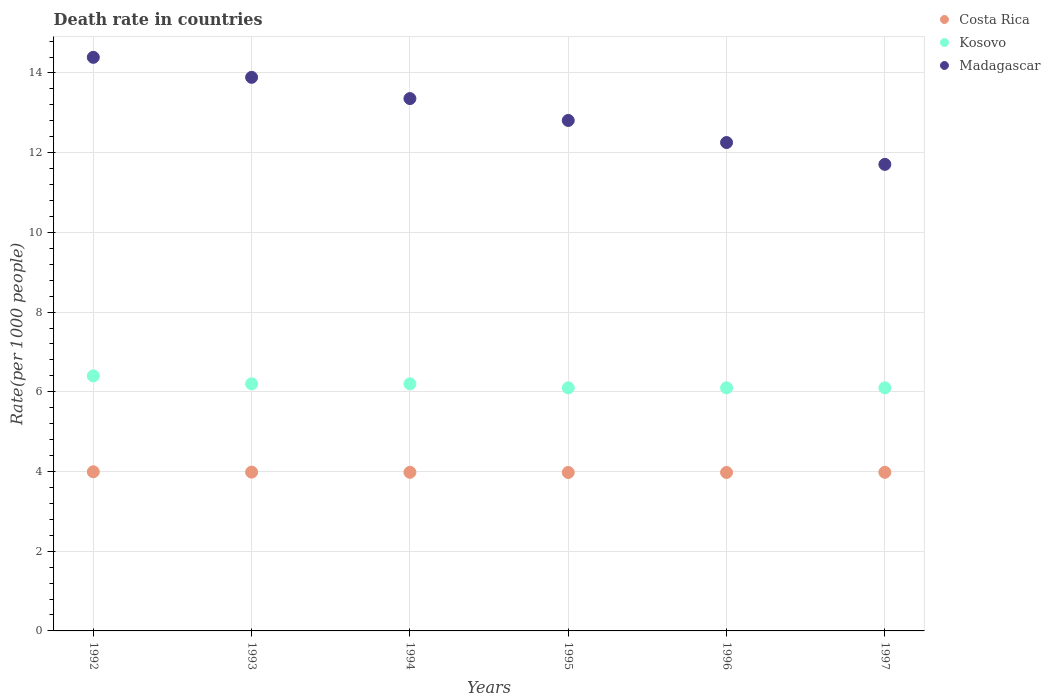How many different coloured dotlines are there?
Offer a terse response. 3. What is the death rate in Madagascar in 1996?
Provide a short and direct response. 12.26. Across all years, what is the maximum death rate in Costa Rica?
Offer a very short reply. 3.99. Across all years, what is the minimum death rate in Costa Rica?
Give a very brief answer. 3.98. In which year was the death rate in Madagascar minimum?
Provide a succinct answer. 1997. What is the total death rate in Costa Rica in the graph?
Keep it short and to the point. 23.89. What is the difference between the death rate in Kosovo in 1996 and that in 1997?
Offer a terse response. 0. What is the difference between the death rate in Costa Rica in 1994 and the death rate in Madagascar in 1996?
Your response must be concise. -8.28. What is the average death rate in Kosovo per year?
Your answer should be very brief. 6.18. In the year 1995, what is the difference between the death rate in Kosovo and death rate in Costa Rica?
Ensure brevity in your answer.  2.12. In how many years, is the death rate in Kosovo greater than 1.2000000000000002?
Offer a very short reply. 6. What is the ratio of the death rate in Madagascar in 1993 to that in 1997?
Your answer should be compact. 1.19. Is the difference between the death rate in Kosovo in 1992 and 1996 greater than the difference between the death rate in Costa Rica in 1992 and 1996?
Offer a terse response. Yes. What is the difference between the highest and the second highest death rate in Kosovo?
Offer a terse response. 0.2. What is the difference between the highest and the lowest death rate in Kosovo?
Provide a short and direct response. 0.3. Is the sum of the death rate in Madagascar in 1994 and 1997 greater than the maximum death rate in Costa Rica across all years?
Keep it short and to the point. Yes. Is it the case that in every year, the sum of the death rate in Costa Rica and death rate in Kosovo  is greater than the death rate in Madagascar?
Offer a very short reply. No. How many dotlines are there?
Your response must be concise. 3. How many years are there in the graph?
Make the answer very short. 6. What is the difference between two consecutive major ticks on the Y-axis?
Provide a short and direct response. 2. Does the graph contain any zero values?
Your answer should be compact. No. Where does the legend appear in the graph?
Ensure brevity in your answer.  Top right. How are the legend labels stacked?
Provide a succinct answer. Vertical. What is the title of the graph?
Offer a terse response. Death rate in countries. Does "Latin America(all income levels)" appear as one of the legend labels in the graph?
Your answer should be compact. No. What is the label or title of the X-axis?
Provide a succinct answer. Years. What is the label or title of the Y-axis?
Ensure brevity in your answer.  Rate(per 1000 people). What is the Rate(per 1000 people) in Costa Rica in 1992?
Keep it short and to the point. 3.99. What is the Rate(per 1000 people) in Madagascar in 1992?
Offer a terse response. 14.39. What is the Rate(per 1000 people) of Costa Rica in 1993?
Your response must be concise. 3.98. What is the Rate(per 1000 people) of Madagascar in 1993?
Make the answer very short. 13.89. What is the Rate(per 1000 people) in Costa Rica in 1994?
Provide a short and direct response. 3.98. What is the Rate(per 1000 people) in Madagascar in 1994?
Ensure brevity in your answer.  13.36. What is the Rate(per 1000 people) in Costa Rica in 1995?
Give a very brief answer. 3.98. What is the Rate(per 1000 people) in Kosovo in 1995?
Your response must be concise. 6.1. What is the Rate(per 1000 people) of Madagascar in 1995?
Your response must be concise. 12.81. What is the Rate(per 1000 people) in Costa Rica in 1996?
Keep it short and to the point. 3.98. What is the Rate(per 1000 people) in Madagascar in 1996?
Offer a terse response. 12.26. What is the Rate(per 1000 people) in Costa Rica in 1997?
Your answer should be compact. 3.98. What is the Rate(per 1000 people) in Kosovo in 1997?
Make the answer very short. 6.1. What is the Rate(per 1000 people) of Madagascar in 1997?
Offer a very short reply. 11.71. Across all years, what is the maximum Rate(per 1000 people) in Costa Rica?
Your answer should be very brief. 3.99. Across all years, what is the maximum Rate(per 1000 people) in Kosovo?
Offer a very short reply. 6.4. Across all years, what is the maximum Rate(per 1000 people) of Madagascar?
Keep it short and to the point. 14.39. Across all years, what is the minimum Rate(per 1000 people) in Costa Rica?
Your response must be concise. 3.98. Across all years, what is the minimum Rate(per 1000 people) in Kosovo?
Offer a very short reply. 6.1. Across all years, what is the minimum Rate(per 1000 people) of Madagascar?
Give a very brief answer. 11.71. What is the total Rate(per 1000 people) in Costa Rica in the graph?
Provide a succinct answer. 23.89. What is the total Rate(per 1000 people) in Kosovo in the graph?
Make the answer very short. 37.1. What is the total Rate(per 1000 people) in Madagascar in the graph?
Provide a short and direct response. 78.41. What is the difference between the Rate(per 1000 people) of Costa Rica in 1992 and that in 1993?
Your answer should be compact. 0.01. What is the difference between the Rate(per 1000 people) in Madagascar in 1992 and that in 1993?
Ensure brevity in your answer.  0.5. What is the difference between the Rate(per 1000 people) of Costa Rica in 1992 and that in 1994?
Offer a terse response. 0.01. What is the difference between the Rate(per 1000 people) in Madagascar in 1992 and that in 1994?
Your response must be concise. 1.03. What is the difference between the Rate(per 1000 people) of Costa Rica in 1992 and that in 1995?
Ensure brevity in your answer.  0.02. What is the difference between the Rate(per 1000 people) of Kosovo in 1992 and that in 1995?
Offer a terse response. 0.3. What is the difference between the Rate(per 1000 people) of Madagascar in 1992 and that in 1995?
Provide a short and direct response. 1.58. What is the difference between the Rate(per 1000 people) of Costa Rica in 1992 and that in 1996?
Offer a terse response. 0.02. What is the difference between the Rate(per 1000 people) in Kosovo in 1992 and that in 1996?
Provide a short and direct response. 0.3. What is the difference between the Rate(per 1000 people) in Madagascar in 1992 and that in 1996?
Keep it short and to the point. 2.14. What is the difference between the Rate(per 1000 people) of Costa Rica in 1992 and that in 1997?
Your answer should be very brief. 0.01. What is the difference between the Rate(per 1000 people) in Kosovo in 1992 and that in 1997?
Your response must be concise. 0.3. What is the difference between the Rate(per 1000 people) of Madagascar in 1992 and that in 1997?
Make the answer very short. 2.69. What is the difference between the Rate(per 1000 people) in Costa Rica in 1993 and that in 1994?
Your answer should be compact. 0.01. What is the difference between the Rate(per 1000 people) of Madagascar in 1993 and that in 1994?
Your response must be concise. 0.53. What is the difference between the Rate(per 1000 people) of Costa Rica in 1993 and that in 1995?
Keep it short and to the point. 0.01. What is the difference between the Rate(per 1000 people) in Madagascar in 1993 and that in 1995?
Offer a terse response. 1.08. What is the difference between the Rate(per 1000 people) of Costa Rica in 1993 and that in 1996?
Keep it short and to the point. 0.01. What is the difference between the Rate(per 1000 people) in Madagascar in 1993 and that in 1996?
Keep it short and to the point. 1.64. What is the difference between the Rate(per 1000 people) of Costa Rica in 1993 and that in 1997?
Offer a terse response. 0.01. What is the difference between the Rate(per 1000 people) of Kosovo in 1993 and that in 1997?
Ensure brevity in your answer.  0.1. What is the difference between the Rate(per 1000 people) in Madagascar in 1993 and that in 1997?
Offer a very short reply. 2.18. What is the difference between the Rate(per 1000 people) in Costa Rica in 1994 and that in 1995?
Your answer should be very brief. 0. What is the difference between the Rate(per 1000 people) in Kosovo in 1994 and that in 1995?
Your answer should be very brief. 0.1. What is the difference between the Rate(per 1000 people) in Madagascar in 1994 and that in 1995?
Ensure brevity in your answer.  0.55. What is the difference between the Rate(per 1000 people) of Costa Rica in 1994 and that in 1996?
Provide a succinct answer. 0. What is the difference between the Rate(per 1000 people) in Madagascar in 1994 and that in 1996?
Give a very brief answer. 1.1. What is the difference between the Rate(per 1000 people) of Costa Rica in 1994 and that in 1997?
Provide a short and direct response. 0. What is the difference between the Rate(per 1000 people) of Madagascar in 1994 and that in 1997?
Your response must be concise. 1.65. What is the difference between the Rate(per 1000 people) in Costa Rica in 1995 and that in 1996?
Provide a short and direct response. 0. What is the difference between the Rate(per 1000 people) in Kosovo in 1995 and that in 1996?
Provide a succinct answer. 0. What is the difference between the Rate(per 1000 people) of Madagascar in 1995 and that in 1996?
Offer a terse response. 0.55. What is the difference between the Rate(per 1000 people) of Costa Rica in 1995 and that in 1997?
Keep it short and to the point. -0. What is the difference between the Rate(per 1000 people) in Kosovo in 1995 and that in 1997?
Give a very brief answer. 0. What is the difference between the Rate(per 1000 people) of Madagascar in 1995 and that in 1997?
Your answer should be very brief. 1.1. What is the difference between the Rate(per 1000 people) of Costa Rica in 1996 and that in 1997?
Provide a succinct answer. -0. What is the difference between the Rate(per 1000 people) in Kosovo in 1996 and that in 1997?
Your response must be concise. 0. What is the difference between the Rate(per 1000 people) in Madagascar in 1996 and that in 1997?
Your answer should be very brief. 0.55. What is the difference between the Rate(per 1000 people) of Costa Rica in 1992 and the Rate(per 1000 people) of Kosovo in 1993?
Give a very brief answer. -2.21. What is the difference between the Rate(per 1000 people) in Costa Rica in 1992 and the Rate(per 1000 people) in Madagascar in 1993?
Provide a short and direct response. -9.9. What is the difference between the Rate(per 1000 people) of Kosovo in 1992 and the Rate(per 1000 people) of Madagascar in 1993?
Provide a succinct answer. -7.49. What is the difference between the Rate(per 1000 people) in Costa Rica in 1992 and the Rate(per 1000 people) in Kosovo in 1994?
Offer a very short reply. -2.21. What is the difference between the Rate(per 1000 people) of Costa Rica in 1992 and the Rate(per 1000 people) of Madagascar in 1994?
Offer a terse response. -9.37. What is the difference between the Rate(per 1000 people) of Kosovo in 1992 and the Rate(per 1000 people) of Madagascar in 1994?
Make the answer very short. -6.96. What is the difference between the Rate(per 1000 people) of Costa Rica in 1992 and the Rate(per 1000 people) of Kosovo in 1995?
Your answer should be very brief. -2.11. What is the difference between the Rate(per 1000 people) in Costa Rica in 1992 and the Rate(per 1000 people) in Madagascar in 1995?
Give a very brief answer. -8.82. What is the difference between the Rate(per 1000 people) in Kosovo in 1992 and the Rate(per 1000 people) in Madagascar in 1995?
Give a very brief answer. -6.41. What is the difference between the Rate(per 1000 people) of Costa Rica in 1992 and the Rate(per 1000 people) of Kosovo in 1996?
Offer a very short reply. -2.11. What is the difference between the Rate(per 1000 people) in Costa Rica in 1992 and the Rate(per 1000 people) in Madagascar in 1996?
Provide a succinct answer. -8.26. What is the difference between the Rate(per 1000 people) in Kosovo in 1992 and the Rate(per 1000 people) in Madagascar in 1996?
Make the answer very short. -5.86. What is the difference between the Rate(per 1000 people) in Costa Rica in 1992 and the Rate(per 1000 people) in Kosovo in 1997?
Your response must be concise. -2.11. What is the difference between the Rate(per 1000 people) of Costa Rica in 1992 and the Rate(per 1000 people) of Madagascar in 1997?
Ensure brevity in your answer.  -7.71. What is the difference between the Rate(per 1000 people) in Kosovo in 1992 and the Rate(per 1000 people) in Madagascar in 1997?
Ensure brevity in your answer.  -5.31. What is the difference between the Rate(per 1000 people) in Costa Rica in 1993 and the Rate(per 1000 people) in Kosovo in 1994?
Ensure brevity in your answer.  -2.21. What is the difference between the Rate(per 1000 people) of Costa Rica in 1993 and the Rate(per 1000 people) of Madagascar in 1994?
Offer a terse response. -9.37. What is the difference between the Rate(per 1000 people) of Kosovo in 1993 and the Rate(per 1000 people) of Madagascar in 1994?
Give a very brief answer. -7.16. What is the difference between the Rate(per 1000 people) of Costa Rica in 1993 and the Rate(per 1000 people) of Kosovo in 1995?
Offer a terse response. -2.12. What is the difference between the Rate(per 1000 people) in Costa Rica in 1993 and the Rate(per 1000 people) in Madagascar in 1995?
Your answer should be very brief. -8.82. What is the difference between the Rate(per 1000 people) in Kosovo in 1993 and the Rate(per 1000 people) in Madagascar in 1995?
Provide a short and direct response. -6.61. What is the difference between the Rate(per 1000 people) in Costa Rica in 1993 and the Rate(per 1000 people) in Kosovo in 1996?
Your answer should be compact. -2.12. What is the difference between the Rate(per 1000 people) of Costa Rica in 1993 and the Rate(per 1000 people) of Madagascar in 1996?
Ensure brevity in your answer.  -8.27. What is the difference between the Rate(per 1000 people) in Kosovo in 1993 and the Rate(per 1000 people) in Madagascar in 1996?
Make the answer very short. -6.05. What is the difference between the Rate(per 1000 people) of Costa Rica in 1993 and the Rate(per 1000 people) of Kosovo in 1997?
Ensure brevity in your answer.  -2.12. What is the difference between the Rate(per 1000 people) of Costa Rica in 1993 and the Rate(per 1000 people) of Madagascar in 1997?
Give a very brief answer. -7.72. What is the difference between the Rate(per 1000 people) in Kosovo in 1993 and the Rate(per 1000 people) in Madagascar in 1997?
Offer a terse response. -5.51. What is the difference between the Rate(per 1000 people) of Costa Rica in 1994 and the Rate(per 1000 people) of Kosovo in 1995?
Offer a terse response. -2.12. What is the difference between the Rate(per 1000 people) in Costa Rica in 1994 and the Rate(per 1000 people) in Madagascar in 1995?
Provide a short and direct response. -8.83. What is the difference between the Rate(per 1000 people) of Kosovo in 1994 and the Rate(per 1000 people) of Madagascar in 1995?
Keep it short and to the point. -6.61. What is the difference between the Rate(per 1000 people) in Costa Rica in 1994 and the Rate(per 1000 people) in Kosovo in 1996?
Your answer should be very brief. -2.12. What is the difference between the Rate(per 1000 people) of Costa Rica in 1994 and the Rate(per 1000 people) of Madagascar in 1996?
Ensure brevity in your answer.  -8.28. What is the difference between the Rate(per 1000 people) of Kosovo in 1994 and the Rate(per 1000 people) of Madagascar in 1996?
Provide a short and direct response. -6.05. What is the difference between the Rate(per 1000 people) in Costa Rica in 1994 and the Rate(per 1000 people) in Kosovo in 1997?
Your answer should be very brief. -2.12. What is the difference between the Rate(per 1000 people) of Costa Rica in 1994 and the Rate(per 1000 people) of Madagascar in 1997?
Provide a short and direct response. -7.73. What is the difference between the Rate(per 1000 people) in Kosovo in 1994 and the Rate(per 1000 people) in Madagascar in 1997?
Your response must be concise. -5.51. What is the difference between the Rate(per 1000 people) in Costa Rica in 1995 and the Rate(per 1000 people) in Kosovo in 1996?
Offer a terse response. -2.12. What is the difference between the Rate(per 1000 people) in Costa Rica in 1995 and the Rate(per 1000 people) in Madagascar in 1996?
Your response must be concise. -8.28. What is the difference between the Rate(per 1000 people) of Kosovo in 1995 and the Rate(per 1000 people) of Madagascar in 1996?
Offer a terse response. -6.16. What is the difference between the Rate(per 1000 people) in Costa Rica in 1995 and the Rate(per 1000 people) in Kosovo in 1997?
Offer a terse response. -2.12. What is the difference between the Rate(per 1000 people) of Costa Rica in 1995 and the Rate(per 1000 people) of Madagascar in 1997?
Give a very brief answer. -7.73. What is the difference between the Rate(per 1000 people) in Kosovo in 1995 and the Rate(per 1000 people) in Madagascar in 1997?
Keep it short and to the point. -5.61. What is the difference between the Rate(per 1000 people) of Costa Rica in 1996 and the Rate(per 1000 people) of Kosovo in 1997?
Your answer should be compact. -2.12. What is the difference between the Rate(per 1000 people) of Costa Rica in 1996 and the Rate(per 1000 people) of Madagascar in 1997?
Your response must be concise. -7.73. What is the difference between the Rate(per 1000 people) of Kosovo in 1996 and the Rate(per 1000 people) of Madagascar in 1997?
Provide a succinct answer. -5.61. What is the average Rate(per 1000 people) of Costa Rica per year?
Your answer should be compact. 3.98. What is the average Rate(per 1000 people) of Kosovo per year?
Provide a succinct answer. 6.18. What is the average Rate(per 1000 people) in Madagascar per year?
Your response must be concise. 13.07. In the year 1992, what is the difference between the Rate(per 1000 people) of Costa Rica and Rate(per 1000 people) of Kosovo?
Make the answer very short. -2.41. In the year 1992, what is the difference between the Rate(per 1000 people) in Costa Rica and Rate(per 1000 people) in Madagascar?
Your response must be concise. -10.4. In the year 1992, what is the difference between the Rate(per 1000 people) of Kosovo and Rate(per 1000 people) of Madagascar?
Give a very brief answer. -7.99. In the year 1993, what is the difference between the Rate(per 1000 people) of Costa Rica and Rate(per 1000 people) of Kosovo?
Your response must be concise. -2.21. In the year 1993, what is the difference between the Rate(per 1000 people) of Costa Rica and Rate(per 1000 people) of Madagascar?
Provide a short and direct response. -9.91. In the year 1993, what is the difference between the Rate(per 1000 people) in Kosovo and Rate(per 1000 people) in Madagascar?
Keep it short and to the point. -7.69. In the year 1994, what is the difference between the Rate(per 1000 people) in Costa Rica and Rate(per 1000 people) in Kosovo?
Your response must be concise. -2.22. In the year 1994, what is the difference between the Rate(per 1000 people) in Costa Rica and Rate(per 1000 people) in Madagascar?
Keep it short and to the point. -9.38. In the year 1994, what is the difference between the Rate(per 1000 people) of Kosovo and Rate(per 1000 people) of Madagascar?
Ensure brevity in your answer.  -7.16. In the year 1995, what is the difference between the Rate(per 1000 people) of Costa Rica and Rate(per 1000 people) of Kosovo?
Provide a short and direct response. -2.12. In the year 1995, what is the difference between the Rate(per 1000 people) of Costa Rica and Rate(per 1000 people) of Madagascar?
Offer a terse response. -8.83. In the year 1995, what is the difference between the Rate(per 1000 people) in Kosovo and Rate(per 1000 people) in Madagascar?
Your answer should be very brief. -6.71. In the year 1996, what is the difference between the Rate(per 1000 people) in Costa Rica and Rate(per 1000 people) in Kosovo?
Make the answer very short. -2.12. In the year 1996, what is the difference between the Rate(per 1000 people) of Costa Rica and Rate(per 1000 people) of Madagascar?
Make the answer very short. -8.28. In the year 1996, what is the difference between the Rate(per 1000 people) in Kosovo and Rate(per 1000 people) in Madagascar?
Give a very brief answer. -6.16. In the year 1997, what is the difference between the Rate(per 1000 people) of Costa Rica and Rate(per 1000 people) of Kosovo?
Provide a succinct answer. -2.12. In the year 1997, what is the difference between the Rate(per 1000 people) in Costa Rica and Rate(per 1000 people) in Madagascar?
Your response must be concise. -7.73. In the year 1997, what is the difference between the Rate(per 1000 people) in Kosovo and Rate(per 1000 people) in Madagascar?
Ensure brevity in your answer.  -5.61. What is the ratio of the Rate(per 1000 people) in Kosovo in 1992 to that in 1993?
Offer a terse response. 1.03. What is the ratio of the Rate(per 1000 people) in Madagascar in 1992 to that in 1993?
Offer a terse response. 1.04. What is the ratio of the Rate(per 1000 people) in Costa Rica in 1992 to that in 1994?
Provide a succinct answer. 1. What is the ratio of the Rate(per 1000 people) in Kosovo in 1992 to that in 1994?
Provide a short and direct response. 1.03. What is the ratio of the Rate(per 1000 people) of Madagascar in 1992 to that in 1994?
Give a very brief answer. 1.08. What is the ratio of the Rate(per 1000 people) of Costa Rica in 1992 to that in 1995?
Offer a terse response. 1. What is the ratio of the Rate(per 1000 people) of Kosovo in 1992 to that in 1995?
Make the answer very short. 1.05. What is the ratio of the Rate(per 1000 people) of Madagascar in 1992 to that in 1995?
Keep it short and to the point. 1.12. What is the ratio of the Rate(per 1000 people) in Costa Rica in 1992 to that in 1996?
Your answer should be very brief. 1. What is the ratio of the Rate(per 1000 people) of Kosovo in 1992 to that in 1996?
Keep it short and to the point. 1.05. What is the ratio of the Rate(per 1000 people) in Madagascar in 1992 to that in 1996?
Give a very brief answer. 1.17. What is the ratio of the Rate(per 1000 people) in Costa Rica in 1992 to that in 1997?
Offer a terse response. 1. What is the ratio of the Rate(per 1000 people) of Kosovo in 1992 to that in 1997?
Your answer should be very brief. 1.05. What is the ratio of the Rate(per 1000 people) in Madagascar in 1992 to that in 1997?
Offer a terse response. 1.23. What is the ratio of the Rate(per 1000 people) in Kosovo in 1993 to that in 1994?
Ensure brevity in your answer.  1. What is the ratio of the Rate(per 1000 people) of Madagascar in 1993 to that in 1994?
Offer a terse response. 1.04. What is the ratio of the Rate(per 1000 people) in Costa Rica in 1993 to that in 1995?
Provide a succinct answer. 1. What is the ratio of the Rate(per 1000 people) in Kosovo in 1993 to that in 1995?
Your answer should be compact. 1.02. What is the ratio of the Rate(per 1000 people) in Madagascar in 1993 to that in 1995?
Offer a terse response. 1.08. What is the ratio of the Rate(per 1000 people) in Kosovo in 1993 to that in 1996?
Offer a very short reply. 1.02. What is the ratio of the Rate(per 1000 people) of Madagascar in 1993 to that in 1996?
Your answer should be compact. 1.13. What is the ratio of the Rate(per 1000 people) in Kosovo in 1993 to that in 1997?
Give a very brief answer. 1.02. What is the ratio of the Rate(per 1000 people) in Madagascar in 1993 to that in 1997?
Your response must be concise. 1.19. What is the ratio of the Rate(per 1000 people) of Kosovo in 1994 to that in 1995?
Your answer should be very brief. 1.02. What is the ratio of the Rate(per 1000 people) in Madagascar in 1994 to that in 1995?
Offer a terse response. 1.04. What is the ratio of the Rate(per 1000 people) in Costa Rica in 1994 to that in 1996?
Ensure brevity in your answer.  1. What is the ratio of the Rate(per 1000 people) of Kosovo in 1994 to that in 1996?
Offer a very short reply. 1.02. What is the ratio of the Rate(per 1000 people) of Madagascar in 1994 to that in 1996?
Your answer should be compact. 1.09. What is the ratio of the Rate(per 1000 people) in Costa Rica in 1994 to that in 1997?
Your response must be concise. 1. What is the ratio of the Rate(per 1000 people) of Kosovo in 1994 to that in 1997?
Ensure brevity in your answer.  1.02. What is the ratio of the Rate(per 1000 people) in Madagascar in 1994 to that in 1997?
Offer a terse response. 1.14. What is the ratio of the Rate(per 1000 people) in Madagascar in 1995 to that in 1996?
Ensure brevity in your answer.  1.05. What is the ratio of the Rate(per 1000 people) of Kosovo in 1995 to that in 1997?
Your answer should be very brief. 1. What is the ratio of the Rate(per 1000 people) in Madagascar in 1995 to that in 1997?
Keep it short and to the point. 1.09. What is the ratio of the Rate(per 1000 people) in Madagascar in 1996 to that in 1997?
Provide a short and direct response. 1.05. What is the difference between the highest and the second highest Rate(per 1000 people) of Costa Rica?
Your answer should be very brief. 0.01. What is the difference between the highest and the second highest Rate(per 1000 people) in Madagascar?
Provide a short and direct response. 0.5. What is the difference between the highest and the lowest Rate(per 1000 people) in Costa Rica?
Make the answer very short. 0.02. What is the difference between the highest and the lowest Rate(per 1000 people) of Kosovo?
Make the answer very short. 0.3. What is the difference between the highest and the lowest Rate(per 1000 people) of Madagascar?
Make the answer very short. 2.69. 